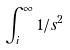<formula> <loc_0><loc_0><loc_500><loc_500>\int _ { i } ^ { \infty } 1 / s ^ { 2 }</formula> 